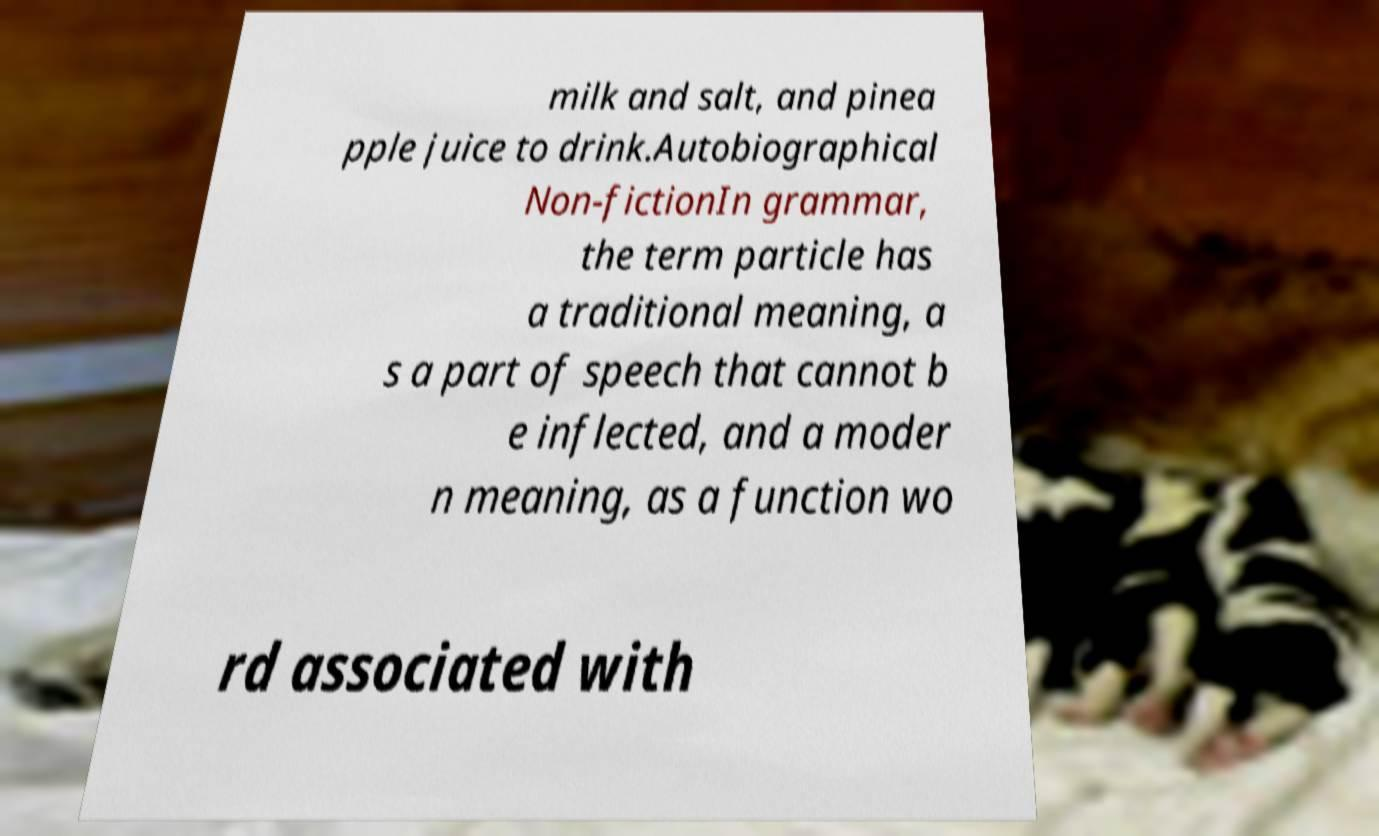Can you read and provide the text displayed in the image?This photo seems to have some interesting text. Can you extract and type it out for me? milk and salt, and pinea pple juice to drink.Autobiographical Non-fictionIn grammar, the term particle has a traditional meaning, a s a part of speech that cannot b e inflected, and a moder n meaning, as a function wo rd associated with 